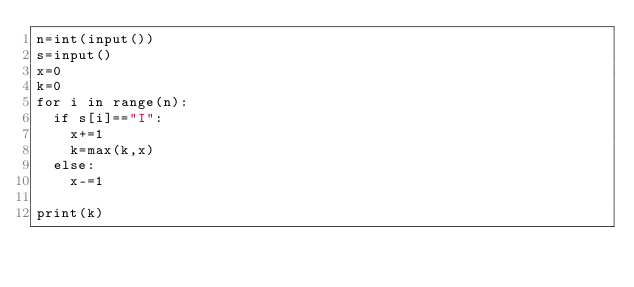Convert code to text. <code><loc_0><loc_0><loc_500><loc_500><_Python_>n=int(input())
s=input()
x=0
k=0
for i in range(n):
  if s[i]=="I":
    x+=1
    k=max(k,x)
  else:
    x-=1
    
print(k)</code> 